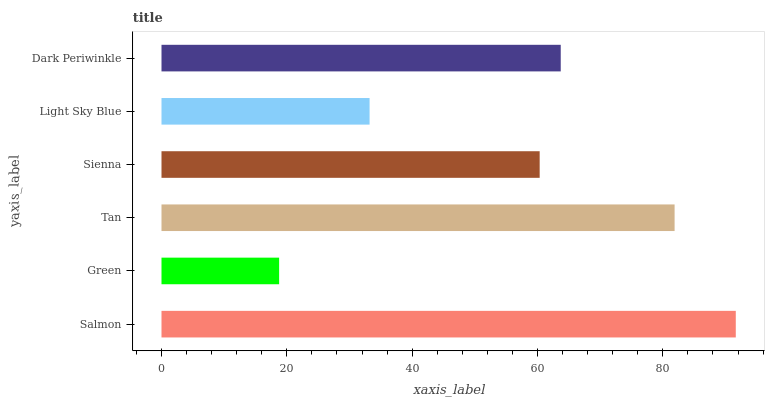Is Green the minimum?
Answer yes or no. Yes. Is Salmon the maximum?
Answer yes or no. Yes. Is Tan the minimum?
Answer yes or no. No. Is Tan the maximum?
Answer yes or no. No. Is Tan greater than Green?
Answer yes or no. Yes. Is Green less than Tan?
Answer yes or no. Yes. Is Green greater than Tan?
Answer yes or no. No. Is Tan less than Green?
Answer yes or no. No. Is Dark Periwinkle the high median?
Answer yes or no. Yes. Is Sienna the low median?
Answer yes or no. Yes. Is Green the high median?
Answer yes or no. No. Is Dark Periwinkle the low median?
Answer yes or no. No. 